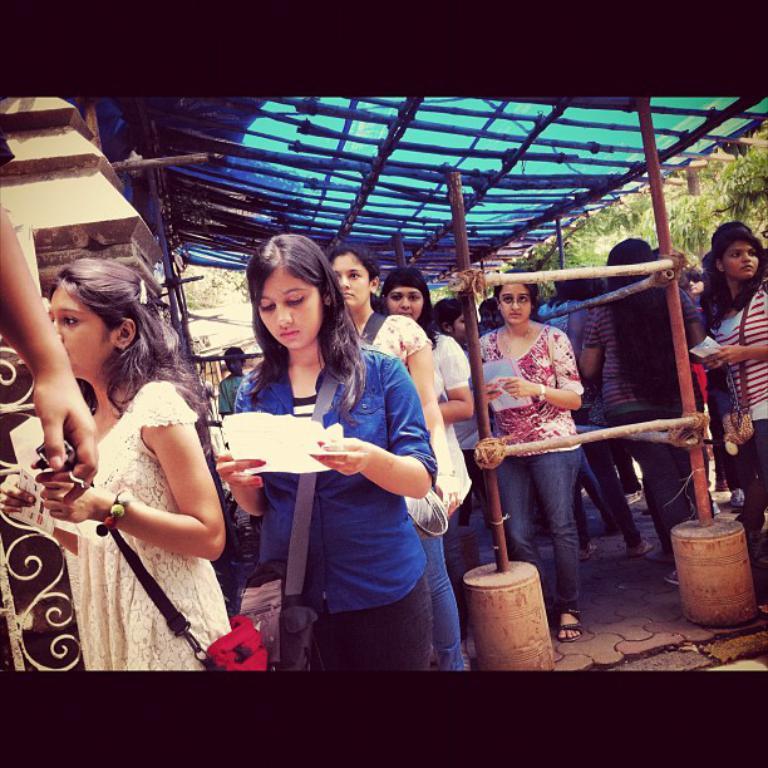Please provide a concise description of this image. In this picture there is a woman who is wearing blue t-shirt and holding a paper. She is wearing a bag. Beside her we can see a woman who is wearing a red bag. At the bag we can see a group of women wear standing under the shed. In the background we can see trees and building. At the bottom right we can see the pipes. 